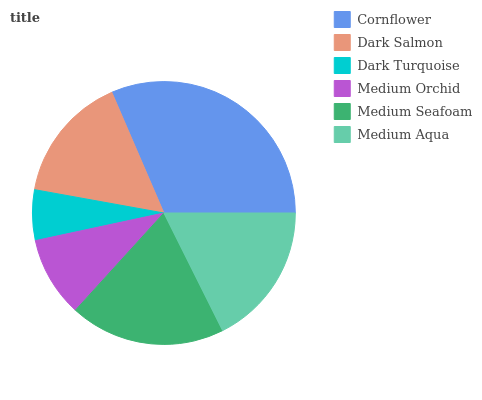Is Dark Turquoise the minimum?
Answer yes or no. Yes. Is Cornflower the maximum?
Answer yes or no. Yes. Is Dark Salmon the minimum?
Answer yes or no. No. Is Dark Salmon the maximum?
Answer yes or no. No. Is Cornflower greater than Dark Salmon?
Answer yes or no. Yes. Is Dark Salmon less than Cornflower?
Answer yes or no. Yes. Is Dark Salmon greater than Cornflower?
Answer yes or no. No. Is Cornflower less than Dark Salmon?
Answer yes or no. No. Is Medium Aqua the high median?
Answer yes or no. Yes. Is Dark Salmon the low median?
Answer yes or no. Yes. Is Medium Seafoam the high median?
Answer yes or no. No. Is Medium Aqua the low median?
Answer yes or no. No. 